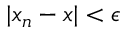Convert formula to latex. <formula><loc_0><loc_0><loc_500><loc_500>| x _ { n } - x | < \epsilon</formula> 